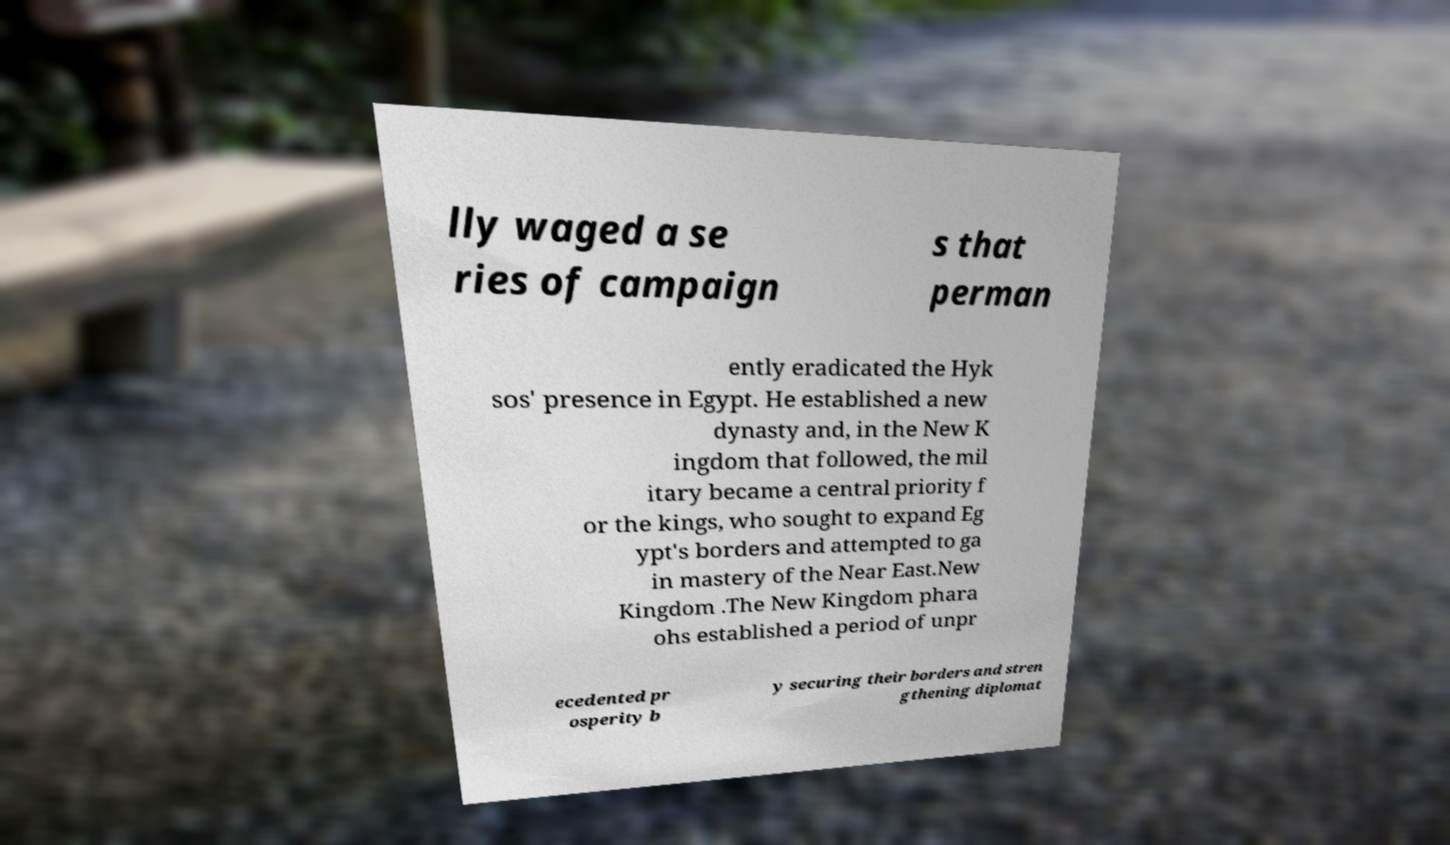Could you assist in decoding the text presented in this image and type it out clearly? lly waged a se ries of campaign s that perman ently eradicated the Hyk sos' presence in Egypt. He established a new dynasty and, in the New K ingdom that followed, the mil itary became a central priority f or the kings, who sought to expand Eg ypt's borders and attempted to ga in mastery of the Near East.New Kingdom .The New Kingdom phara ohs established a period of unpr ecedented pr osperity b y securing their borders and stren gthening diplomat 